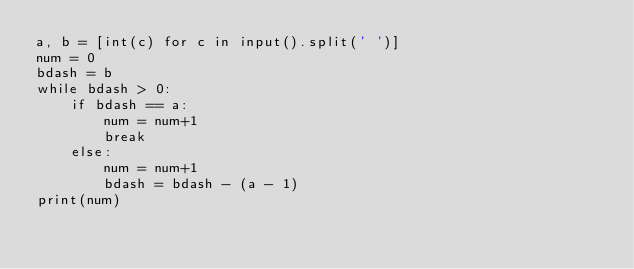<code> <loc_0><loc_0><loc_500><loc_500><_Python_>a, b = [int(c) for c in input().split(' ')]
num = 0
bdash = b
while bdash > 0:
    if bdash == a:
        num = num+1
        break
    else:
        num = num+1
        bdash = bdash - (a - 1)
print(num)

</code> 